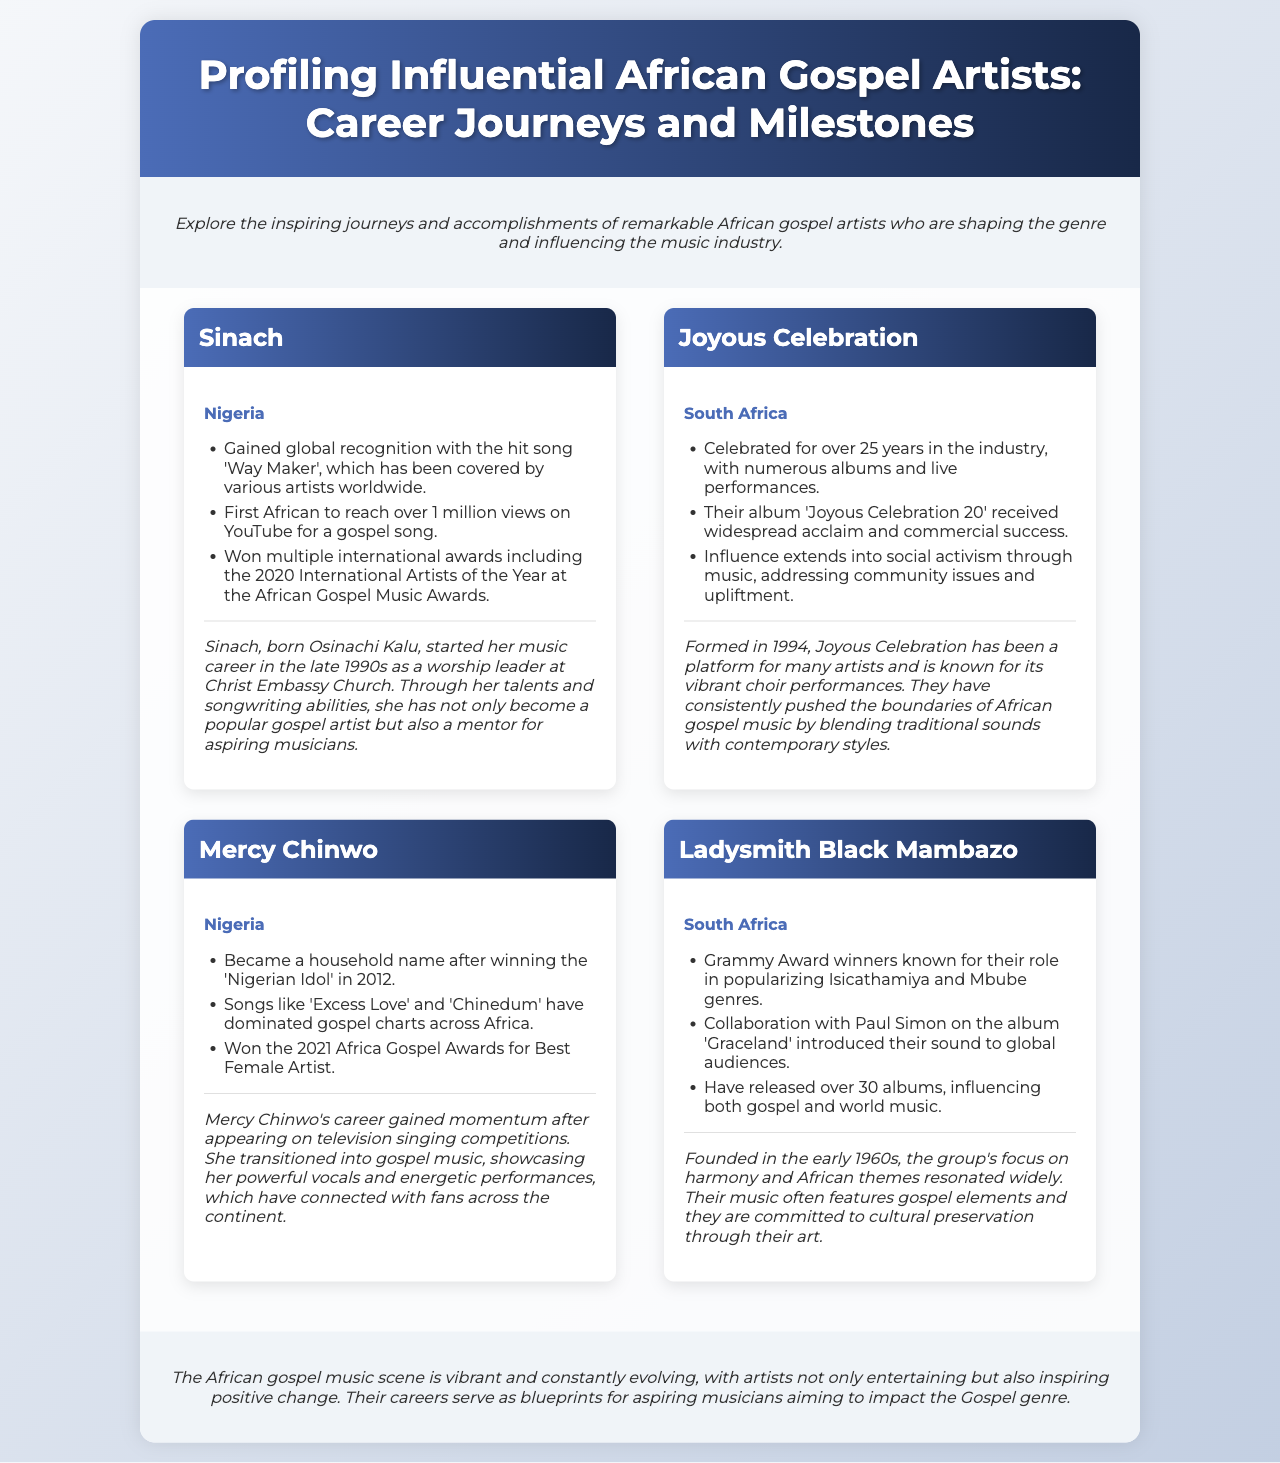what is the name of the first artist profiled? The first artist listed in the document is Sinach.
Answer: Sinach which country is Joyous Celebration from? Joyous Celebration is identified as being from South Africa.
Answer: South Africa how many years has Joyous Celebration been in the industry? The document states that Joyous Celebration has been celebrated for over 25 years.
Answer: 25 years which song propelled Mercy Chinwo to fame? The document indicates that Mercy Chinwo became a household name after winning the Nigerian Idol in 2012.
Answer: Nigerian Idol which award did Sinach win in 2020? The document notes that Sinach won the 2020 International Artists of the Year at the African Gospel Music Awards.
Answer: International Artists of the Year what year was Ladysmith Black Mambazo founded? The document mentions that the group was founded in the early 1960s.
Answer: early 1960s what is a common theme in the music of Ladysmith Black Mambazo? The document highlights that their music often features gospel elements and focuses on cultural preservation.
Answer: gospel elements name one song by Mercy Chinwo that has dominated gospel charts. The document lists 'Excess Love' as one of her songs that have dominated gospel charts across Africa.
Answer: Excess Love how does the document describe the African gospel music scene? The document describes it as vibrant and constantly evolving, with artists inspiring positive change.
Answer: vibrant and constantly evolving 